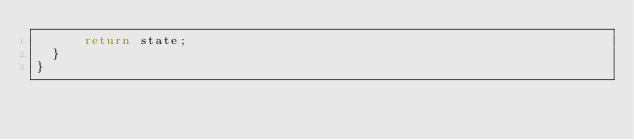Convert code to text. <code><loc_0><loc_0><loc_500><loc_500><_JavaScript_>      return state;
  }
}
</code> 